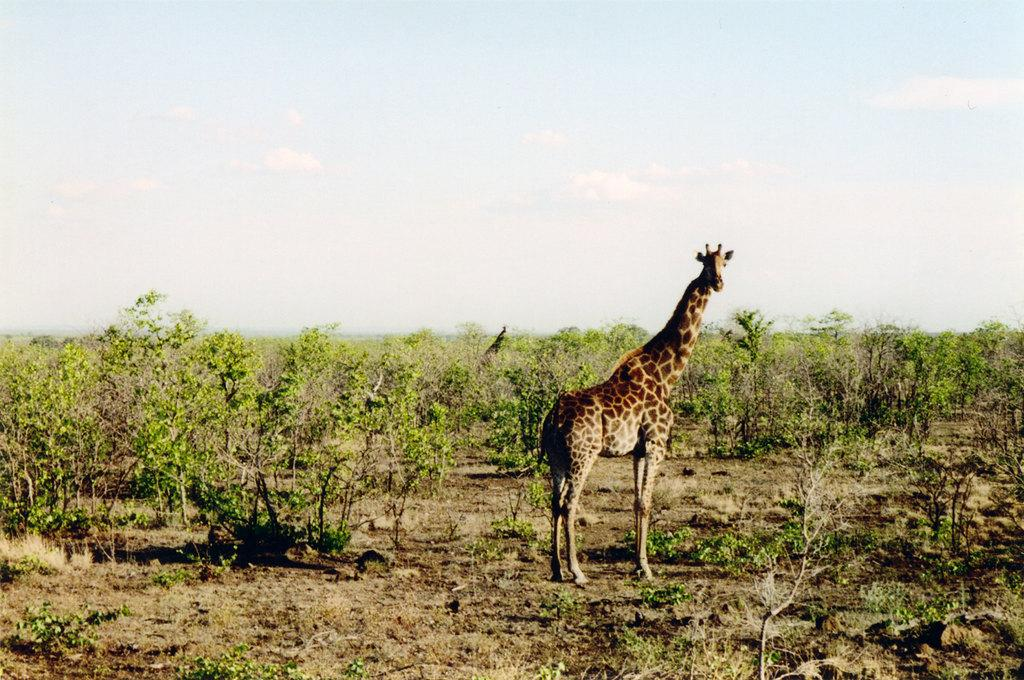What type of animal is in the image? There is a giraffe in the image. What else can be seen in the image besides the giraffe? There are plants in the image. What can be seen in the background of the image? The sky is visible in the background of the image. What type of oil is being used to create the art in the image? There is no art or oil present in the image; it features a giraffe and plants. 